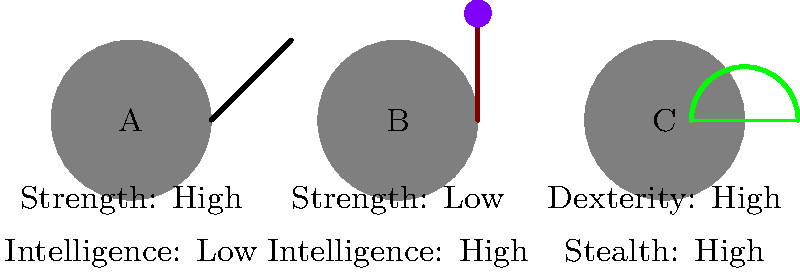Based on the visual equipment and attributes shown for characters A, B, and C, which character is most likely to be a Wizard in a typical RPG setting? To identify the Wizard character, let's analyze the equipment and attributes for each character:

1. Character A:
   - Equipment: Sword
   - Attributes: High Strength, Low Intelligence
   - This combination suggests a melee fighter, not a Wizard.

2. Character B:
   - Equipment: Staff
   - Attributes: Low Strength, High Intelligence
   - This combination is typical for a Wizard in RPGs.

3. Character C:
   - Equipment: Bow
   - Attributes: High Dexterity, High Stealth
   - This combination suggests a ranged fighter or rogue, not a Wizard.

Wizards in RPGs typically have the following characteristics:
- They use staffs or wands as their primary weapons.
- They have high Intelligence, which is crucial for spellcasting.
- They often have low physical attributes like Strength.

Based on these factors, Character B matches the typical profile of a Wizard in RPG settings.
Answer: Character B 